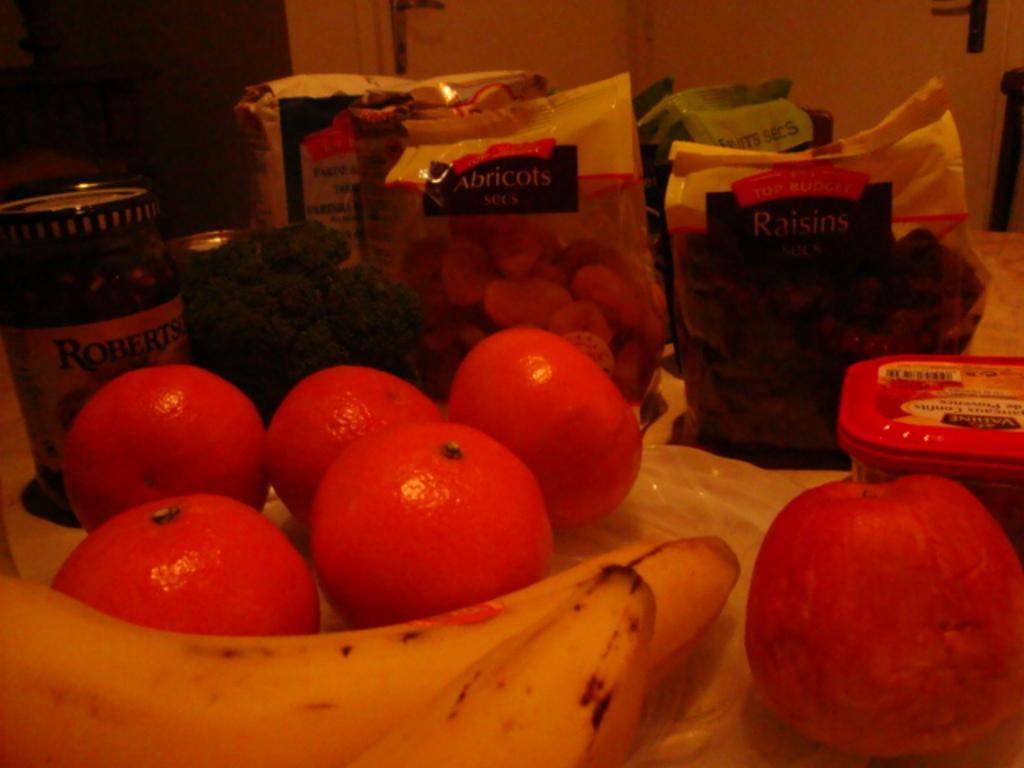Could you give a brief overview of what you see in this image? In this image we can see some fruits, tins, box, and some packets on the table, also we can see the wall. 